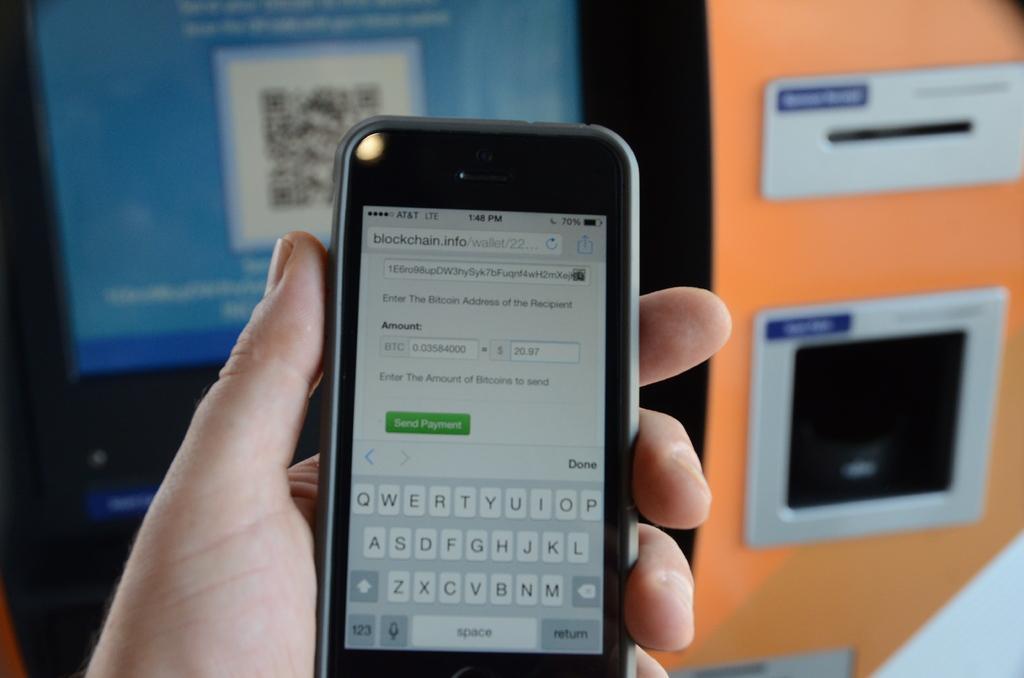In one or two sentences, can you explain what this image depicts? In this picture I can see there is a smart phone, a person is holding it and in the backdrop I can see there is a orange color object and it has a slot. 